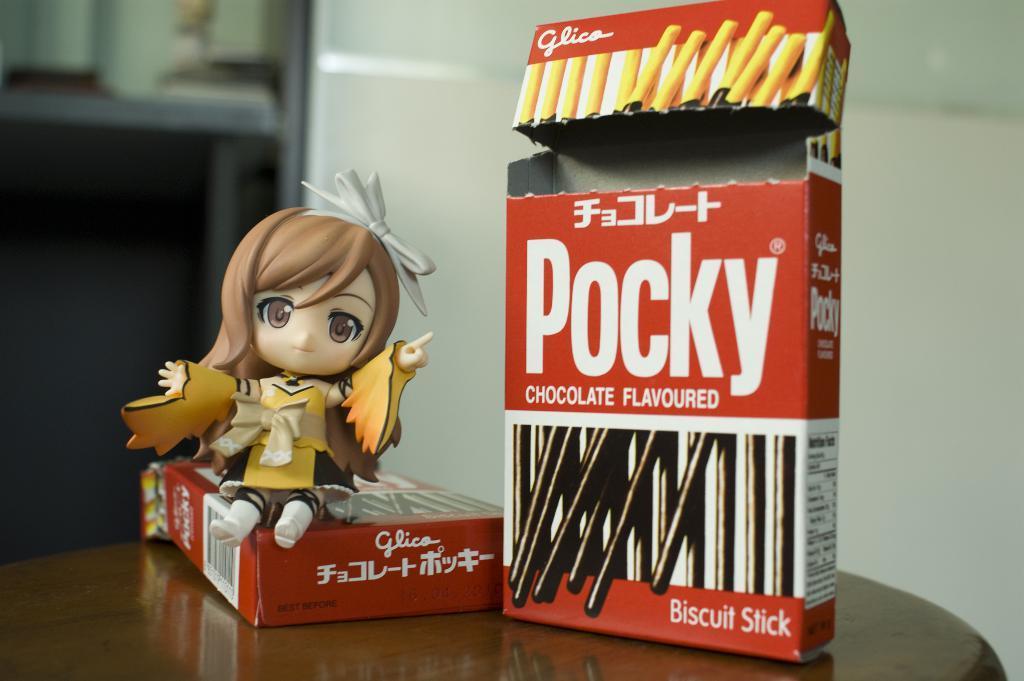Can you describe this image briefly? In this picture we can see two boxes and a toy of a girl on a table and in the background we can see the wall and it is blurry. 